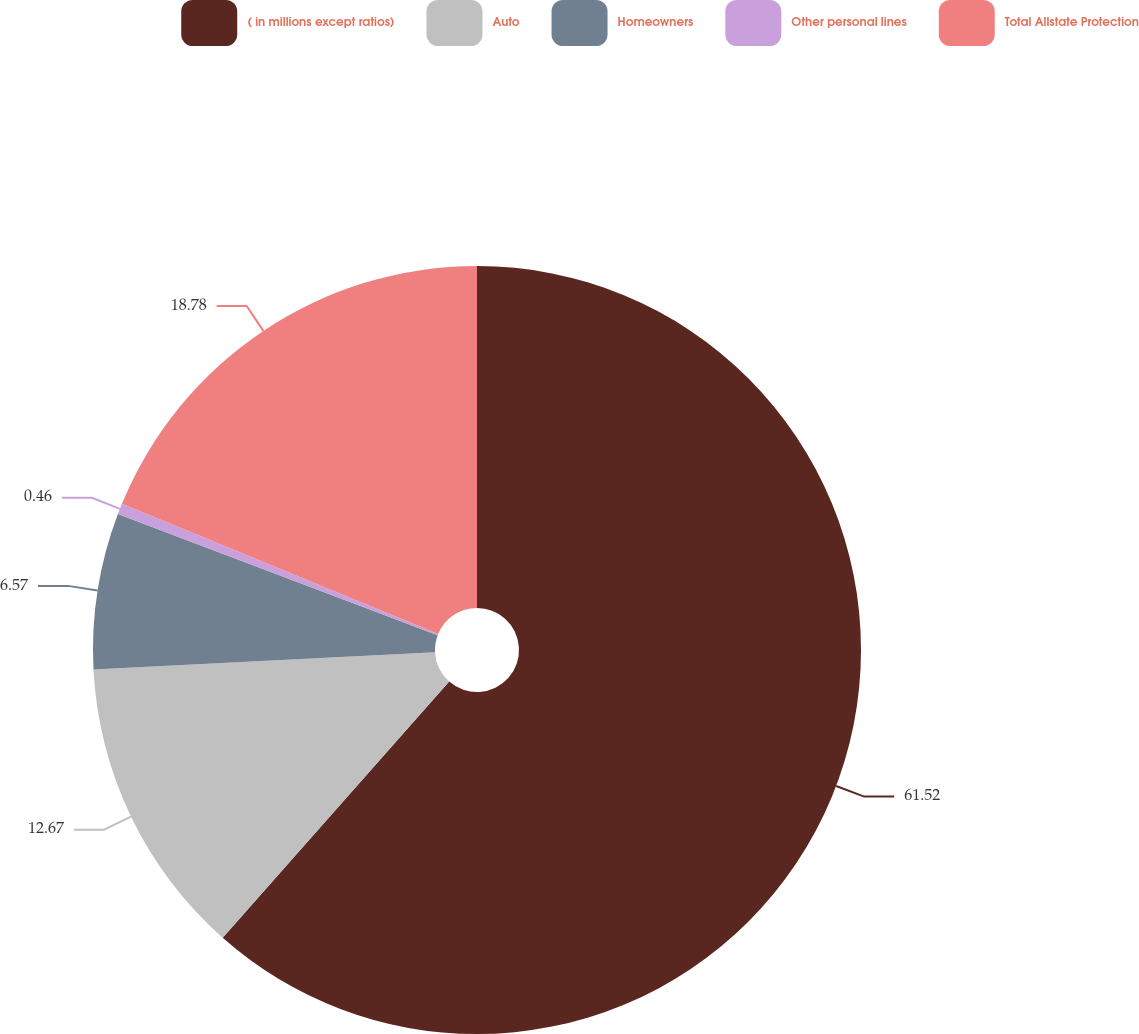Convert chart. <chart><loc_0><loc_0><loc_500><loc_500><pie_chart><fcel>( in millions except ratios)<fcel>Auto<fcel>Homeowners<fcel>Other personal lines<fcel>Total Allstate Protection<nl><fcel>61.52%<fcel>12.67%<fcel>6.57%<fcel>0.46%<fcel>18.78%<nl></chart> 